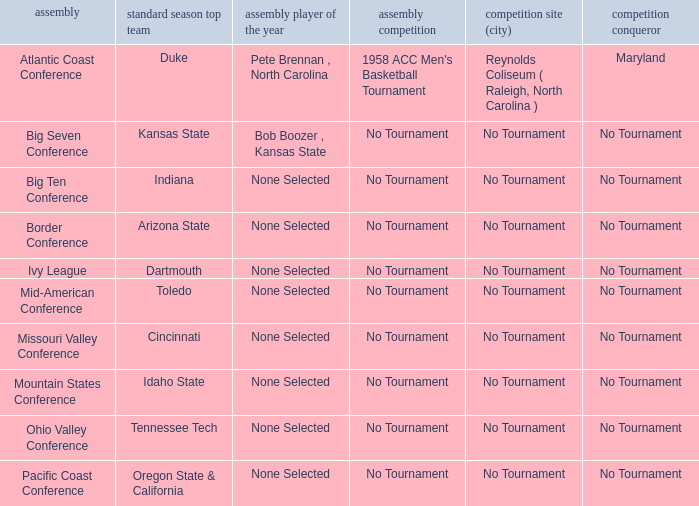Who won the regular season when Missouri Valley Conference took place? Cincinnati. 